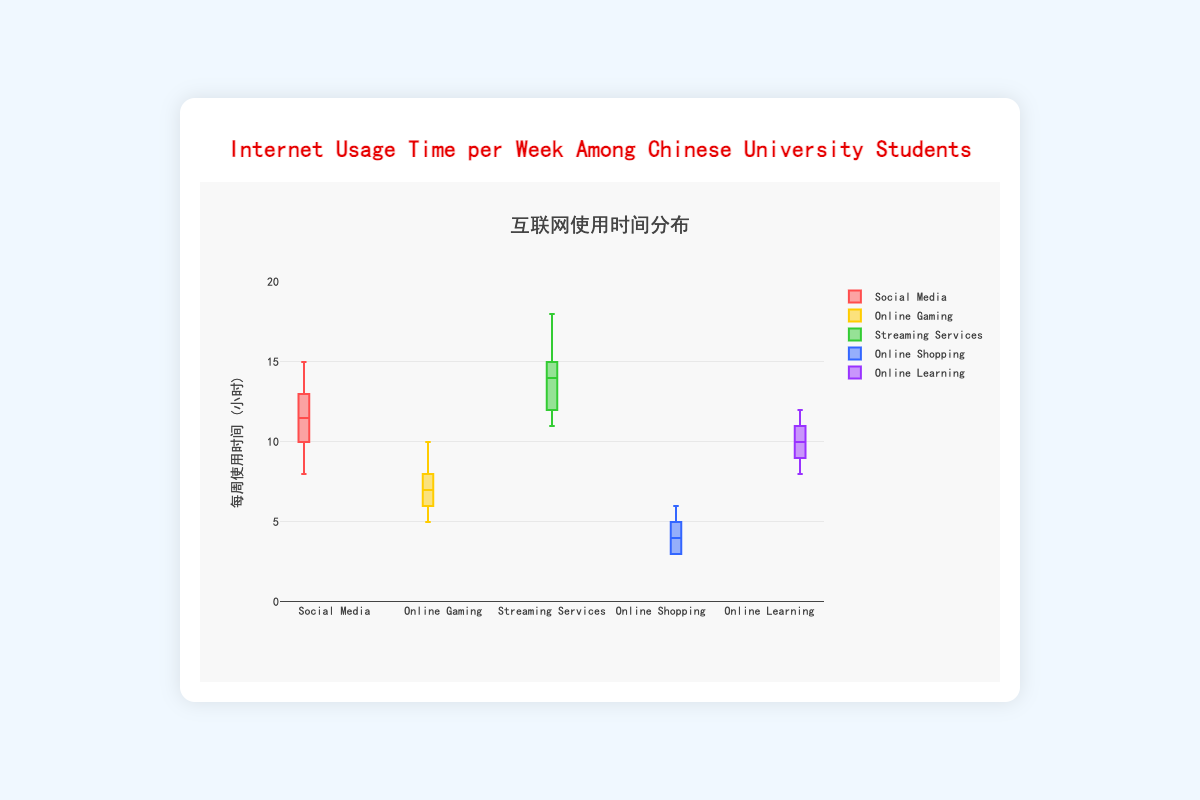What is the title of the figure? The title of the figure is displayed at the top center in both English and Chinese. The English text is "Internet Usage Time per Week Among Chinese University Students" and the Chinese text is "互联网使用时间分布".
Answer: Internet Usage Time per Week Among Chinese University Students What is the average weekly usage time for Social Media activities? The weekly usage times for Social Media activities are [10, 12, 8, 15, 11, 14, 9, 13, 10, 12]. Summing these values gives 114, and there are 10 values, so the average is 114 / 10 = 11.4 hours.
Answer: 11.4 hours Which type of online activity has the highest median weekly usage time? The median is the middle value of a sorted list. For the five activity types: Social Media (median = 11), Online Gaming (median = 7), Streaming Services (median = 14.5), Online Shopping (median = 4), and Online Learning (median = 10). Comparing these values, the highest median is 14.5 for Streaming Services.
Answer: Streaming Services How does the range of weekly usage times for Social Media compare to that of Online Shopping? The range is the difference between the maximum and minimum values. For Social Media, the range is 15 - 8 = 7 hours. For Online Shopping, the range is 6 - 3 = 3 hours. The range for Social Media is greater than that for Online Shopping.
Answer: Social Media has a greater range What is the interquartile range (IQR) for Online Learning activities? The IQR is the difference between the 75th percentile (Q3) and the 25th percentile (Q1). For Online Learning, Q1 is 9 and Q3 is 11, so the IQR is 11 - 9 = 2 hours.
Answer: 2 hours Which online activity has the widest spread of weekly usage times? The spread can be assessed by the range or variance. Social Media (range = 7), Online Gaming (range = 5), Streaming Services (range = 7), Online Shopping (range = 3), and Online Learning (range = 4). Both Social Media and Streaming Services have a range of 7 hours, indicating the widest spread.
Answer: Social Media and Streaming Services Are there any outliers in the data? Outliers are values significantly higher or lower than the rest of the data. By examining the box plots, none of the activities show points outside the whiskers, indicating there are no outliers.
Answer: No What is the median weekly usage time for Online Gaming activities? The weekly usage times for Online Gaming are [5, 6, 6, 7, 7, 8, 8, 9, 10]. Sorting these values, the middle value (median) is 7 hours.
Answer: 7 hours Compare the upper quartile (Q3) of Streaming Services to the upper quartile of Online Learning. For Streaming Services, Q3 is 15 hours, and for Online Learning, Q3 is 11 hours. The Q3 for Streaming Services is higher than that for Online Learning.
Answer: Streaming Services is higher 